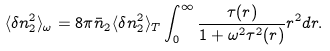<formula> <loc_0><loc_0><loc_500><loc_500>\langle \delta n _ { 2 } ^ { 2 } \rangle _ { \omega } = 8 \pi \bar { n } _ { 2 } \langle \delta n _ { 2 } ^ { 2 } \rangle _ { T } \int _ { 0 } ^ { \infty } \frac { \tau ( r ) } { 1 + \omega ^ { 2 } \tau ^ { 2 } ( r ) } r ^ { 2 } d r .</formula> 